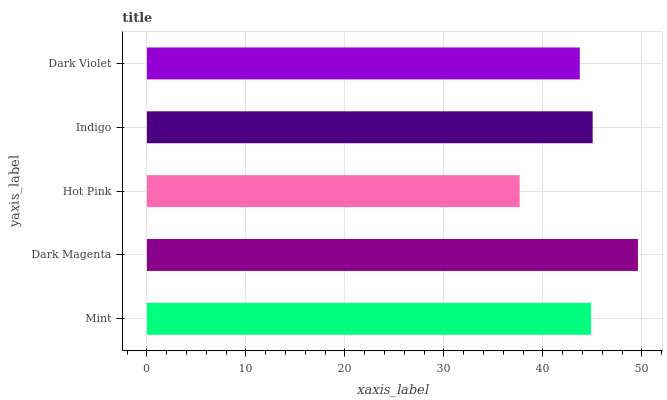Is Hot Pink the minimum?
Answer yes or no. Yes. Is Dark Magenta the maximum?
Answer yes or no. Yes. Is Dark Magenta the minimum?
Answer yes or no. No. Is Hot Pink the maximum?
Answer yes or no. No. Is Dark Magenta greater than Hot Pink?
Answer yes or no. Yes. Is Hot Pink less than Dark Magenta?
Answer yes or no. Yes. Is Hot Pink greater than Dark Magenta?
Answer yes or no. No. Is Dark Magenta less than Hot Pink?
Answer yes or no. No. Is Mint the high median?
Answer yes or no. Yes. Is Mint the low median?
Answer yes or no. Yes. Is Hot Pink the high median?
Answer yes or no. No. Is Dark Violet the low median?
Answer yes or no. No. 